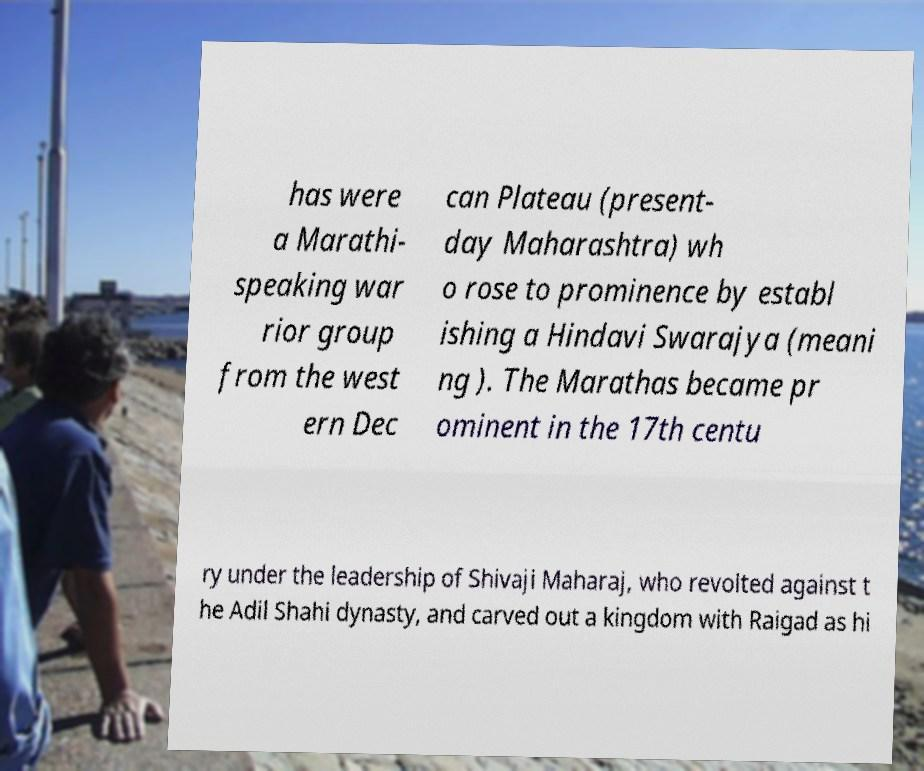For documentation purposes, I need the text within this image transcribed. Could you provide that? has were a Marathi- speaking war rior group from the west ern Dec can Plateau (present- day Maharashtra) wh o rose to prominence by establ ishing a Hindavi Swarajya (meani ng ). The Marathas became pr ominent in the 17th centu ry under the leadership of Shivaji Maharaj, who revolted against t he Adil Shahi dynasty, and carved out a kingdom with Raigad as hi 